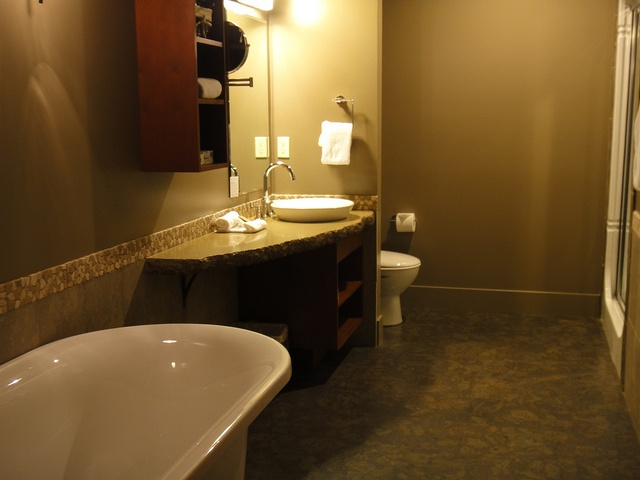Describe the objects in this image and their specific colors. I can see sink in olive, ivory, and tan tones and toilet in olive, maroon, tan, and black tones in this image. 